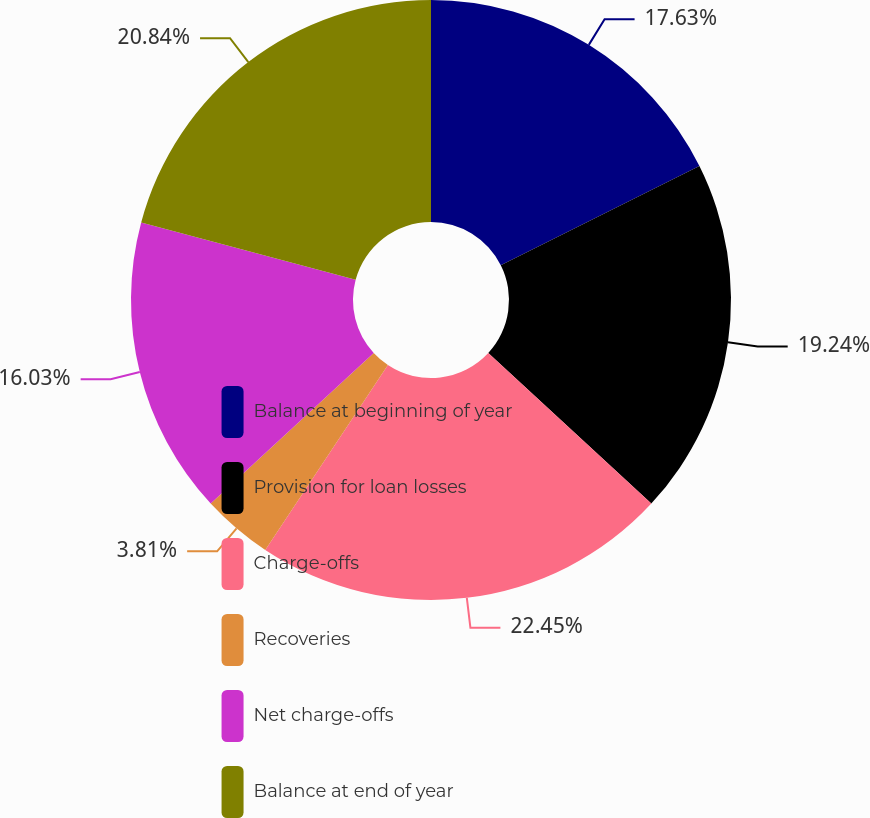Convert chart to OTSL. <chart><loc_0><loc_0><loc_500><loc_500><pie_chart><fcel>Balance at beginning of year<fcel>Provision for loan losses<fcel>Charge-offs<fcel>Recoveries<fcel>Net charge-offs<fcel>Balance at end of year<nl><fcel>17.63%<fcel>19.24%<fcel>22.44%<fcel>3.81%<fcel>16.03%<fcel>20.84%<nl></chart> 